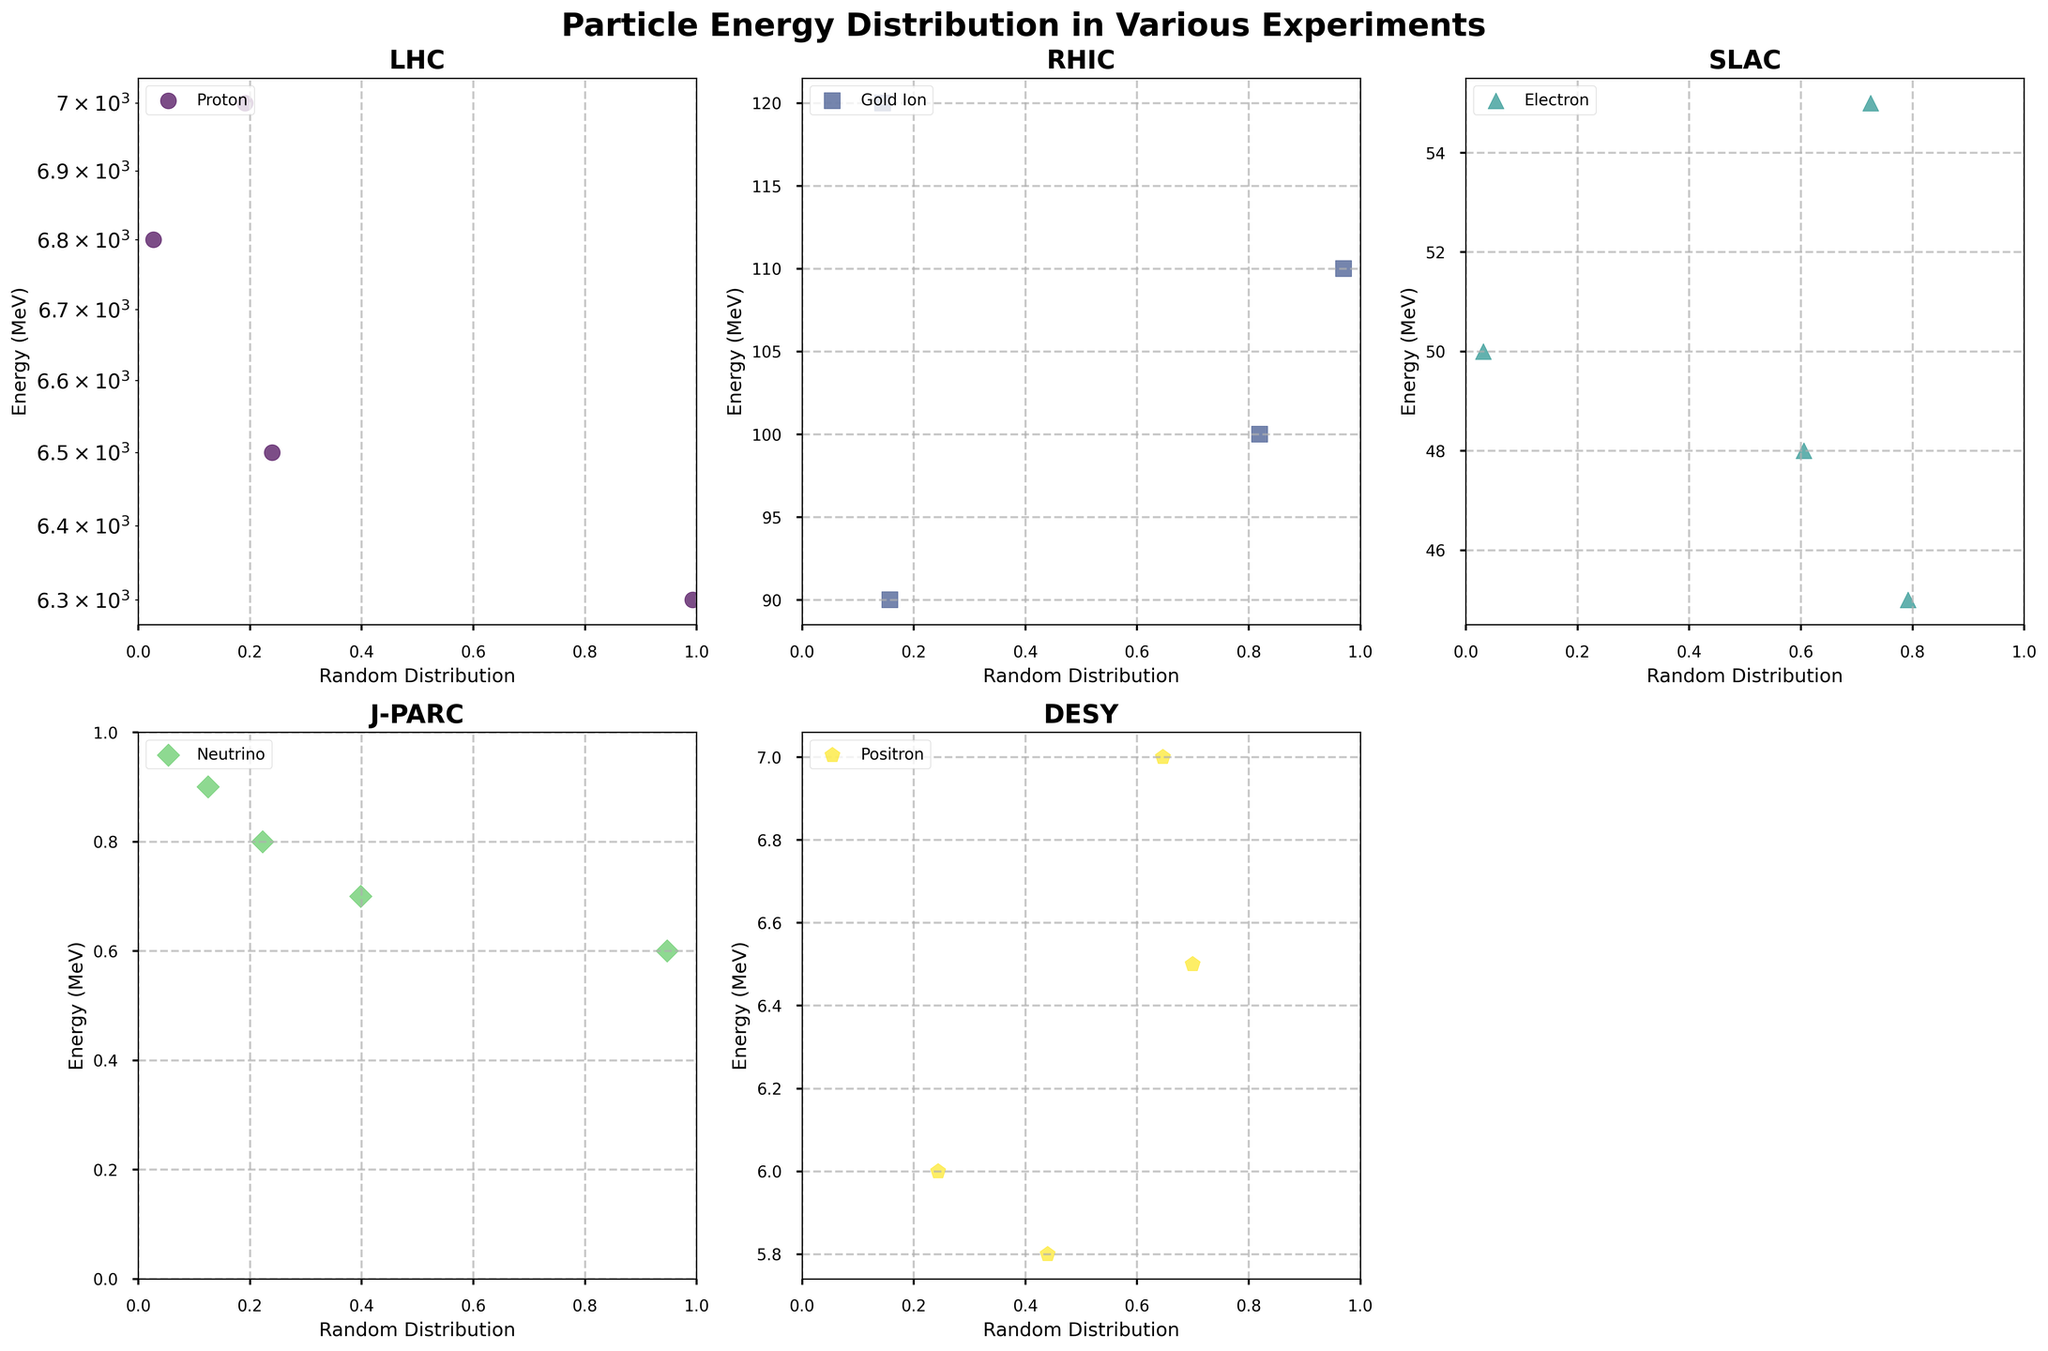What is the title of the figure? The title is displayed at the top center of the figure and reads: 'Particle Energy Distribution in Various Experiments'
Answer: Particle Energy Distribution in Various Experiments How many experiments are shown in the figure? By counting the subplots, it's clear there are subplots for LHC, RHIC, SLAC, J-PARC, and DESY, which means there are 5 experiments shown.
Answer: 5 Which particle's energy distribution is displayed on the logarithmic scale? The subplot for LHC uses a logarithmic y-scale, showing the energy distribution of Protons.
Answer: Proton (LHC) Which experiment has the lowest maximum energy? By inspecting the y-axes of the subplots, J-PARC's Neutrino distribution is the one with the lowest maximum energy (0.9 MeV)
Answer: J-PARC What are the names of the particles analyzed in the DESY experiment? The legend in the DESY subplot shows the particle name as Positron
Answer: Positron What is the range of energies observed in the RHIC experiment? The y-axis for the RHIC subplot shows energy values ranging from 90 MeV to 120 MeV
Answer: 90 to 120 MeV Which experiment shows the energy distribution of Electrons? Observing the legends of the subplots, the SLAC subplot shows the energy distribution of Electrons
Answer: SLAC How do the energies of particles in LHC compare to those in RHIC? The y-axes indicate that LHC particle energies (6500 to 7000 MeV) are much higher than those in RHIC (90 to 120 MeV)
Answer: LHC energies are higher Which experiment has the most varied marker shapes in the scatter plot? By comparing scatter plot markers, each subplot uses distinct markers, but LHC has the most varied shapes (circles)
Answer: All subplots have varied markers, none are more varied What are the different colors used in the scatter plots? Observing the colors in the subplots, various shades from the 'viridis' colormap are used, including greens, blues, and purples
Answer: Greens, blues, purples 